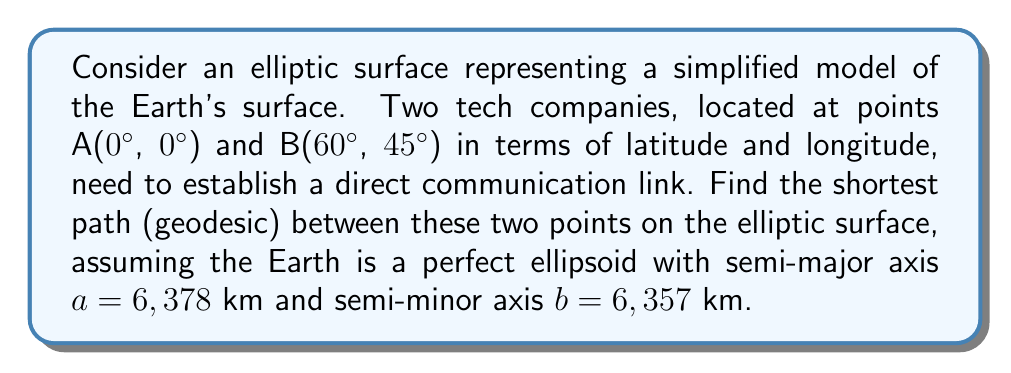Teach me how to tackle this problem. To find the shortest path (geodesic) between two points on an elliptic surface, we'll use the following steps:

1. Convert the given coordinates to radians:
   A: (0°, 0°) = (0, 0) radians
   B: (60°, 45°) = ($\frac{\pi}{3}$, $\frac{\pi}{4}$) radians

2. Use the ellipsoidal version of the Vincenty's formula, which is more accurate for ellipsoidal surfaces than the great circle distance formula.

3. The Vincenty's formula for the distance $s$ between two points on an ellipsoid is:

   $$s = b \cdot A(\sin U_1 \cos U_2 + \cos U_1 \sin U_2 \cos \lambda)$$

   Where:
   - $b$ is the semi-minor axis
   - $A$ is the equatorial radius of curvature
   - $U_1$ and $U_2$ are reduced latitudes
   - $\lambda$ is the difference in longitude

4. Calculate the reduced latitudes:
   $$\tan U = (1-f) \tan \phi$$
   Where $f$ is the flattening of the ellipsoid: $f = \frac{a-b}{a} \approx 0.003353$

   $U_1 = \arctan((1-f) \tan 0) = 0$
   $U_2 = \arctan((1-f) \tan \frac{\pi}{4}) \approx 0.7853$

5. Calculate $\lambda = \frac{\pi}{3}$ (difference in longitude)

6. Calculate the equatorial radius of curvature:
   $$A = \frac{a}{\sqrt{1 - e^2 \sin^2 \frac{\phi_1 + \phi_2}{2}}}$$
   Where $e^2 = \frac{a^2 - b^2}{a^2} \approx 0.006694$

   $A \approx 6,375.55$ km

7. Apply the Vincenty's formula:
   $$s = 6357 \cdot 6375.55 (\sin 0 \cos 0.7853 + \cos 0 \sin 0.7853 \cos \frac{\pi}{3})$$

8. Simplify and calculate:
   $$s \approx 6357 \cdot 6375.55 \cdot 0.5566 \approx 22,507.7 \text{ km}$$

Therefore, the shortest path (geodesic) between the two points on the elliptic surface is approximately 22,507.7 km.
Answer: 22,507.7 km 